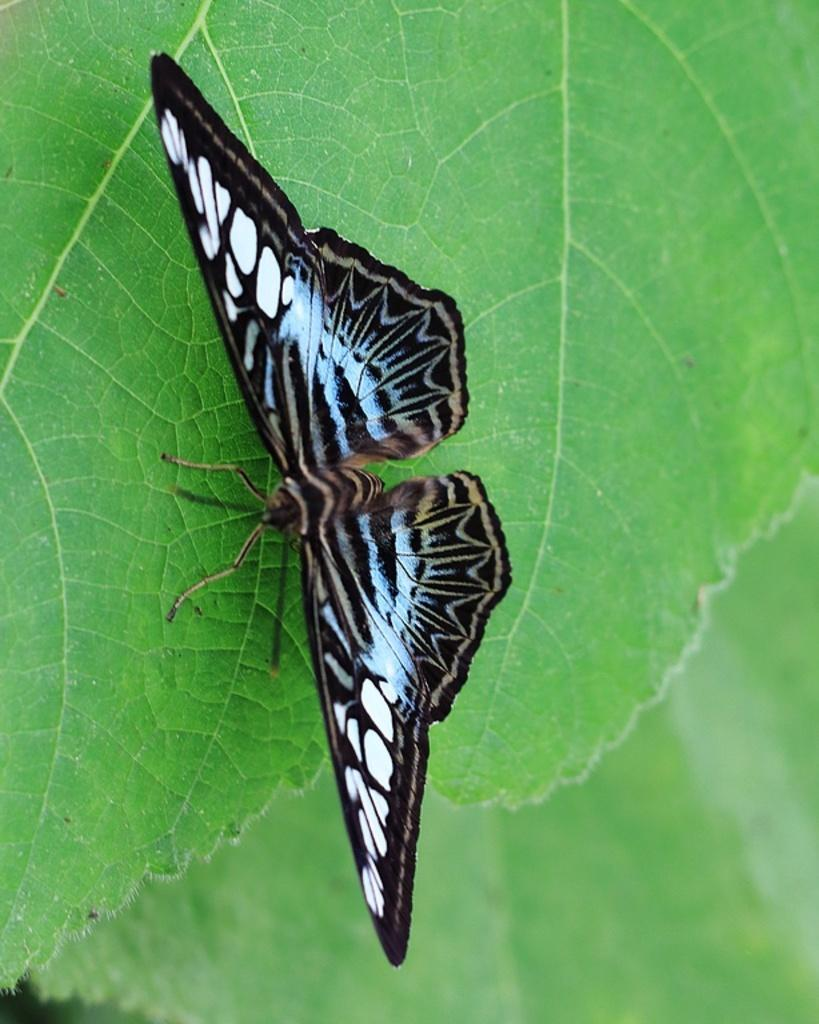What is the main subject of the picture? The main subject of the picture is a butterfly. What is the butterfly doing in the picture? The butterfly is standing on a leaf in the picture. Are there any other leaves visible in the image? Yes, there is another leaf visible at the bottom of the image. What type of religious symbol can be seen on the leaf in the image? There is no religious symbol present on the leaf in the image; it only features a butterfly standing on it. 